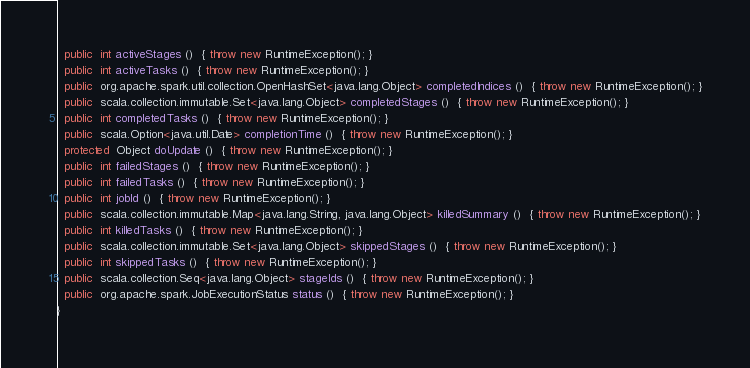<code> <loc_0><loc_0><loc_500><loc_500><_Java_>  public  int activeStages ()  { throw new RuntimeException(); }
  public  int activeTasks ()  { throw new RuntimeException(); }
  public  org.apache.spark.util.collection.OpenHashSet<java.lang.Object> completedIndices ()  { throw new RuntimeException(); }
  public  scala.collection.immutable.Set<java.lang.Object> completedStages ()  { throw new RuntimeException(); }
  public  int completedTasks ()  { throw new RuntimeException(); }
  public  scala.Option<java.util.Date> completionTime ()  { throw new RuntimeException(); }
  protected  Object doUpdate ()  { throw new RuntimeException(); }
  public  int failedStages ()  { throw new RuntimeException(); }
  public  int failedTasks ()  { throw new RuntimeException(); }
  public  int jobId ()  { throw new RuntimeException(); }
  public  scala.collection.immutable.Map<java.lang.String, java.lang.Object> killedSummary ()  { throw new RuntimeException(); }
  public  int killedTasks ()  { throw new RuntimeException(); }
  public  scala.collection.immutable.Set<java.lang.Object> skippedStages ()  { throw new RuntimeException(); }
  public  int skippedTasks ()  { throw new RuntimeException(); }
  public  scala.collection.Seq<java.lang.Object> stageIds ()  { throw new RuntimeException(); }
  public  org.apache.spark.JobExecutionStatus status ()  { throw new RuntimeException(); }
}
</code> 